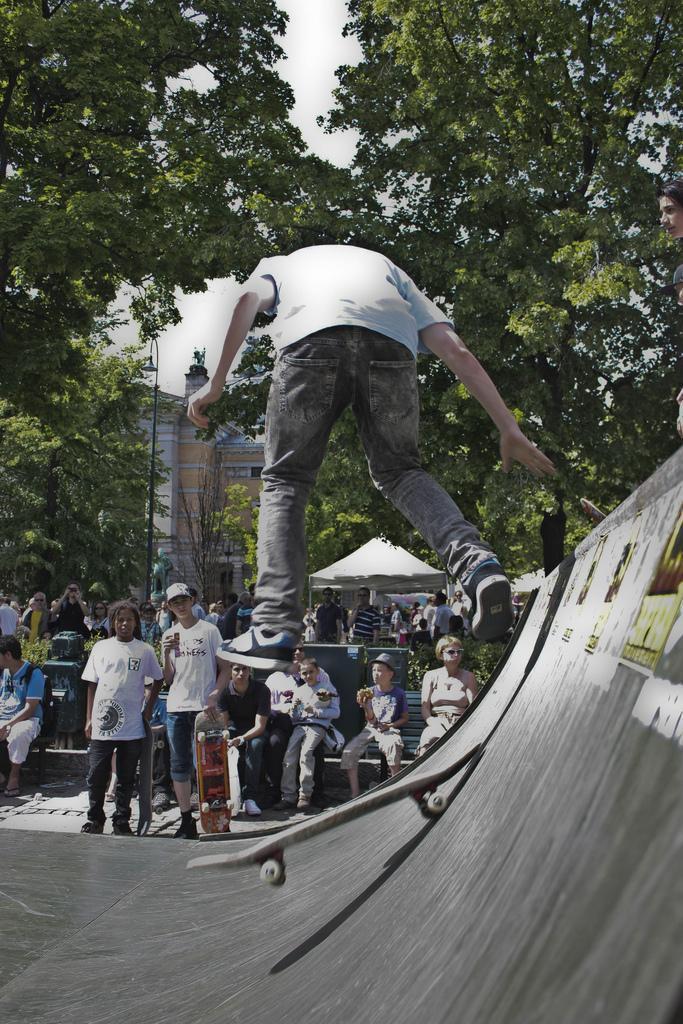How many people on the bench are wearing hats?
Give a very brief answer. 1. How many people standing are holding skateboards?
Give a very brief answer. 2. How many white canopy tents?
Give a very brief answer. 1. How many people in blue and white striped shirts?
Give a very brief answer. 1. How many ramps are shown?
Give a very brief answer. 1. 